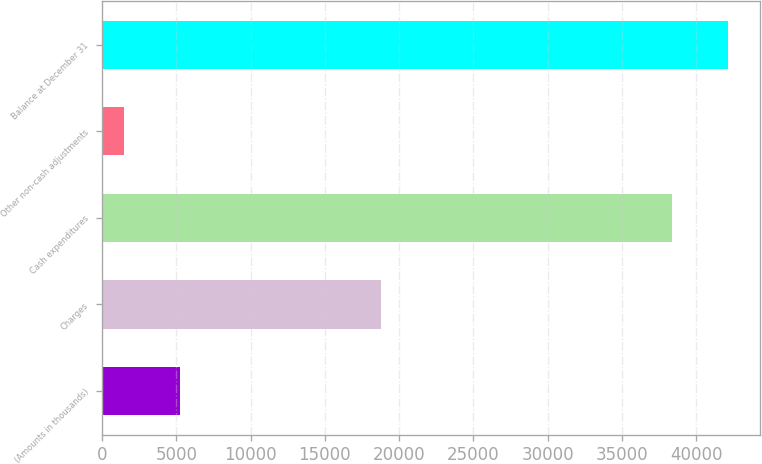Convert chart to OTSL. <chart><loc_0><loc_0><loc_500><loc_500><bar_chart><fcel>(Amounts in thousands)<fcel>Charges<fcel>Cash expenditures<fcel>Other non-cash adjustments<fcel>Balance at December 31<nl><fcel>5227.1<fcel>18743<fcel>38391<fcel>1449<fcel>42169.1<nl></chart> 